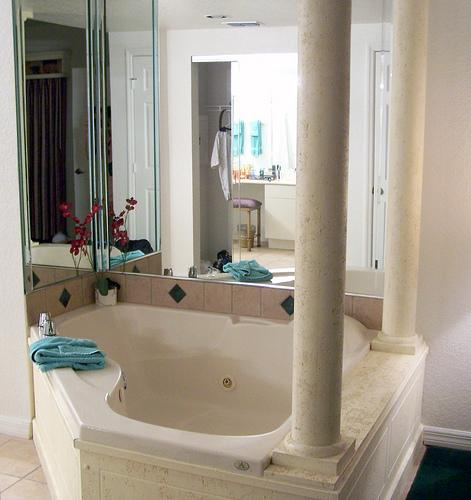What is the purpose of the round objects in the tub? Please explain your reasoning. massage. The purpose is a massage. 